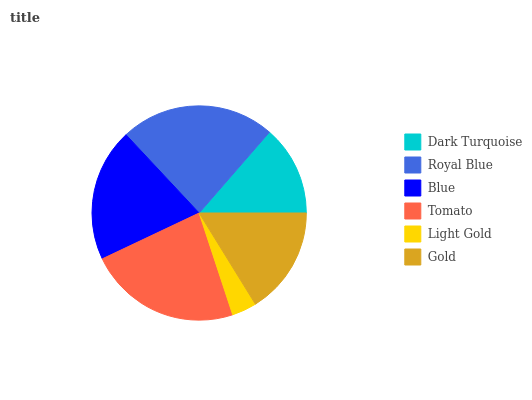Is Light Gold the minimum?
Answer yes or no. Yes. Is Royal Blue the maximum?
Answer yes or no. Yes. Is Blue the minimum?
Answer yes or no. No. Is Blue the maximum?
Answer yes or no. No. Is Royal Blue greater than Blue?
Answer yes or no. Yes. Is Blue less than Royal Blue?
Answer yes or no. Yes. Is Blue greater than Royal Blue?
Answer yes or no. No. Is Royal Blue less than Blue?
Answer yes or no. No. Is Blue the high median?
Answer yes or no. Yes. Is Gold the low median?
Answer yes or no. Yes. Is Royal Blue the high median?
Answer yes or no. No. Is Light Gold the low median?
Answer yes or no. No. 